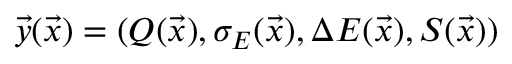Convert formula to latex. <formula><loc_0><loc_0><loc_500><loc_500>\vec { y } ( \vec { x } ) = ( Q ( \vec { x } ) , \sigma _ { E } ( \vec { x } ) , \Delta E ( \vec { x } ) , S ( \vec { x } ) )</formula> 